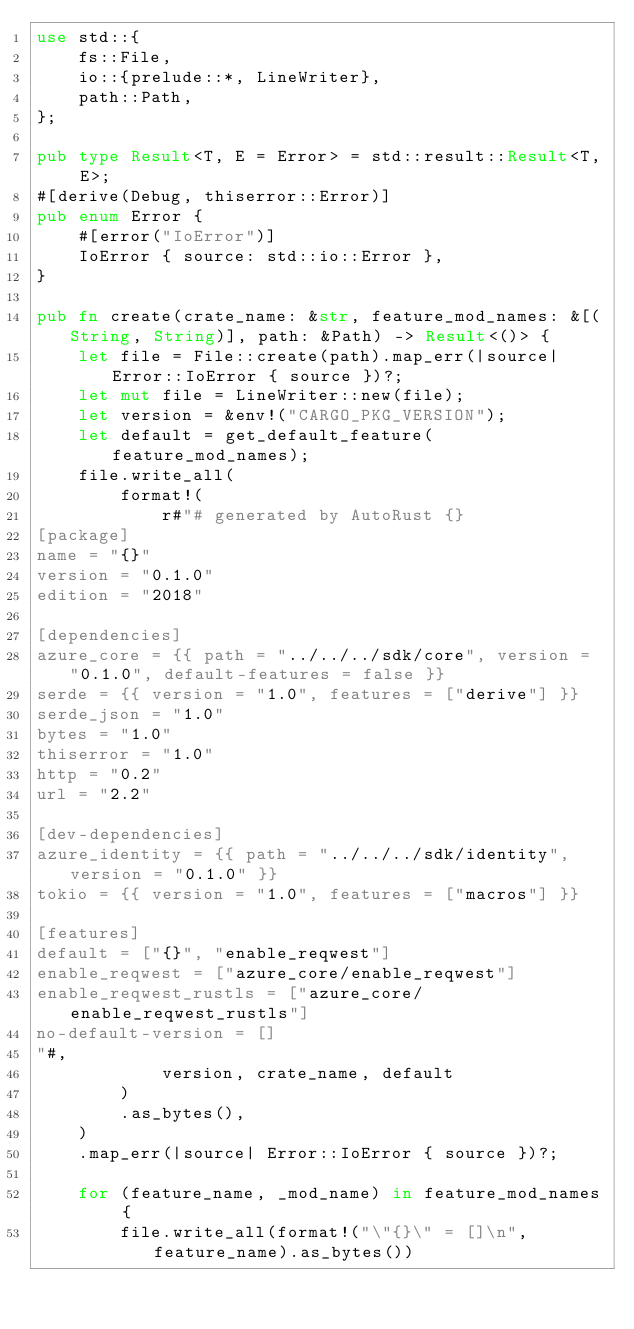<code> <loc_0><loc_0><loc_500><loc_500><_Rust_>use std::{
    fs::File,
    io::{prelude::*, LineWriter},
    path::Path,
};

pub type Result<T, E = Error> = std::result::Result<T, E>;
#[derive(Debug, thiserror::Error)]
pub enum Error {
    #[error("IoError")]
    IoError { source: std::io::Error },
}

pub fn create(crate_name: &str, feature_mod_names: &[(String, String)], path: &Path) -> Result<()> {
    let file = File::create(path).map_err(|source| Error::IoError { source })?;
    let mut file = LineWriter::new(file);
    let version = &env!("CARGO_PKG_VERSION");
    let default = get_default_feature(feature_mod_names);
    file.write_all(
        format!(
            r#"# generated by AutoRust {}
[package]
name = "{}"
version = "0.1.0"
edition = "2018"

[dependencies]
azure_core = {{ path = "../../../sdk/core", version = "0.1.0", default-features = false }}
serde = {{ version = "1.0", features = ["derive"] }}
serde_json = "1.0"
bytes = "1.0"
thiserror = "1.0"
http = "0.2"
url = "2.2"

[dev-dependencies]
azure_identity = {{ path = "../../../sdk/identity", version = "0.1.0" }}
tokio = {{ version = "1.0", features = ["macros"] }}

[features]
default = ["{}", "enable_reqwest"]
enable_reqwest = ["azure_core/enable_reqwest"]
enable_reqwest_rustls = ["azure_core/enable_reqwest_rustls"]
no-default-version = []
"#,
            version, crate_name, default
        )
        .as_bytes(),
    )
    .map_err(|source| Error::IoError { source })?;

    for (feature_name, _mod_name) in feature_mod_names {
        file.write_all(format!("\"{}\" = []\n", feature_name).as_bytes())</code> 